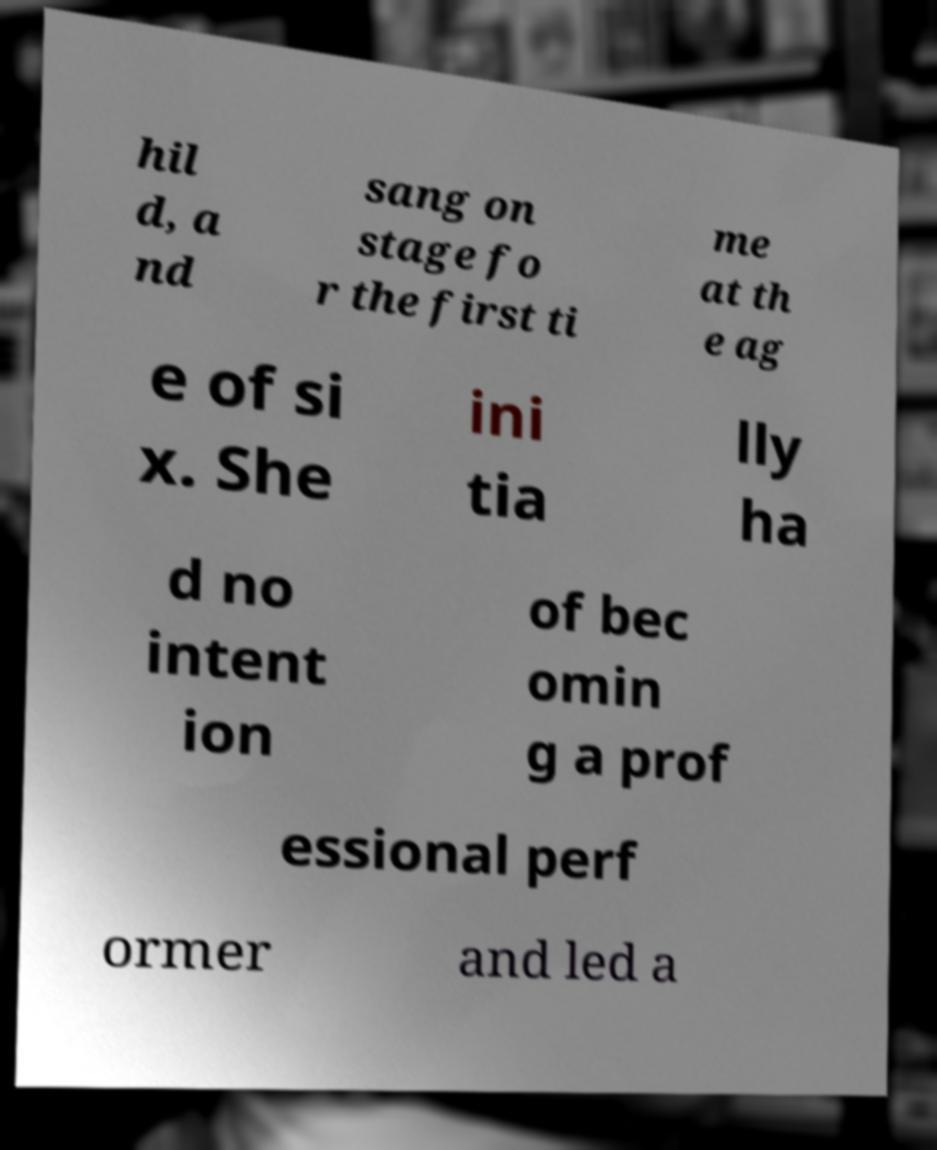What messages or text are displayed in this image? I need them in a readable, typed format. hil d, a nd sang on stage fo r the first ti me at th e ag e of si x. She ini tia lly ha d no intent ion of bec omin g a prof essional perf ormer and led a 